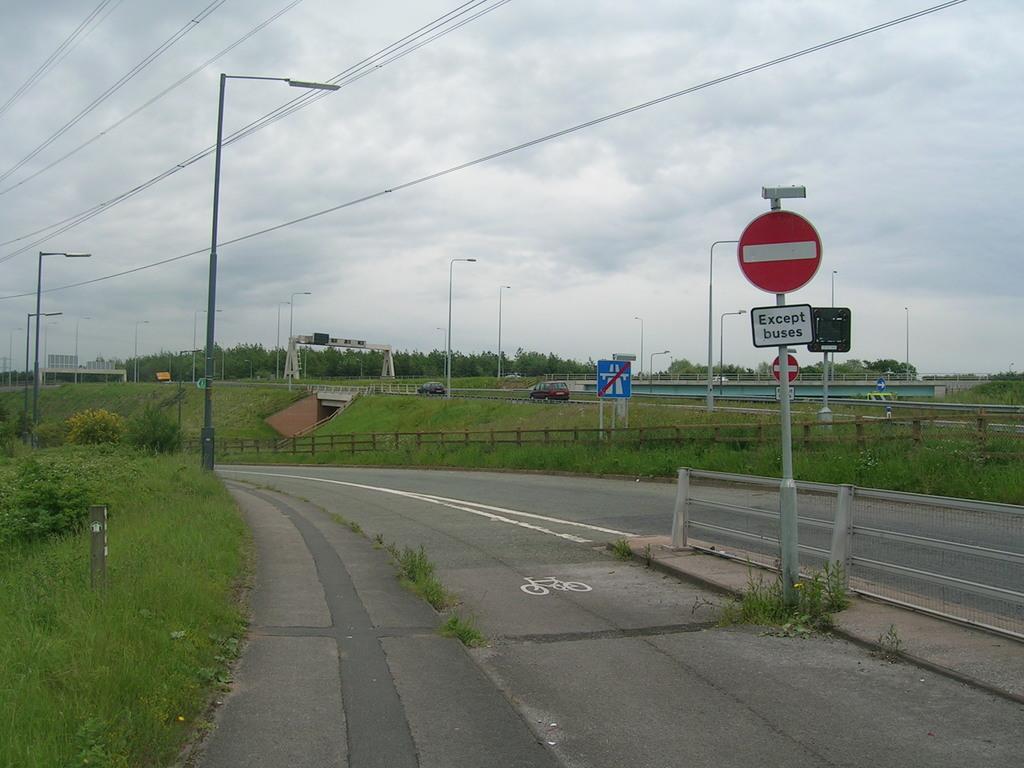What does the street sign read?
Give a very brief answer. Except buses. 